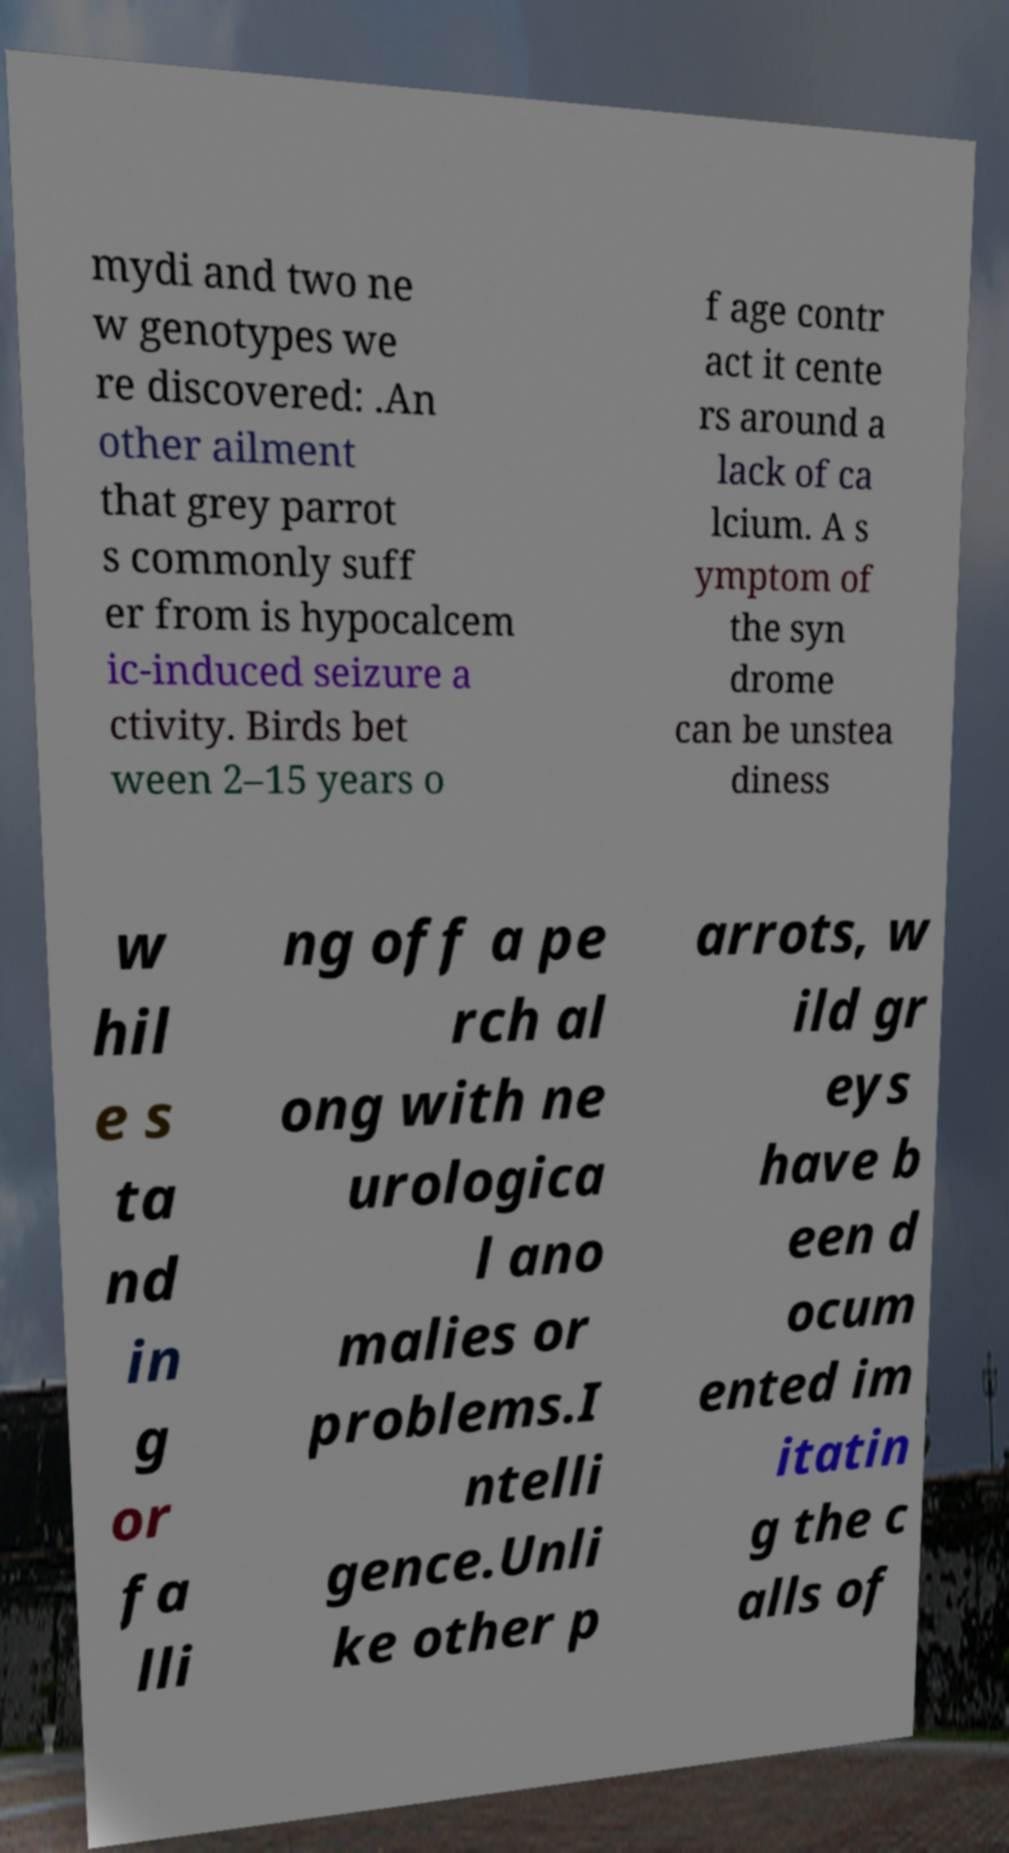For documentation purposes, I need the text within this image transcribed. Could you provide that? mydi and two ne w genotypes we re discovered: .An other ailment that grey parrot s commonly suff er from is hypocalcem ic-induced seizure a ctivity. Birds bet ween 2–15 years o f age contr act it cente rs around a lack of ca lcium. A s ymptom of the syn drome can be unstea diness w hil e s ta nd in g or fa lli ng off a pe rch al ong with ne urologica l ano malies or problems.I ntelli gence.Unli ke other p arrots, w ild gr eys have b een d ocum ented im itatin g the c alls of 